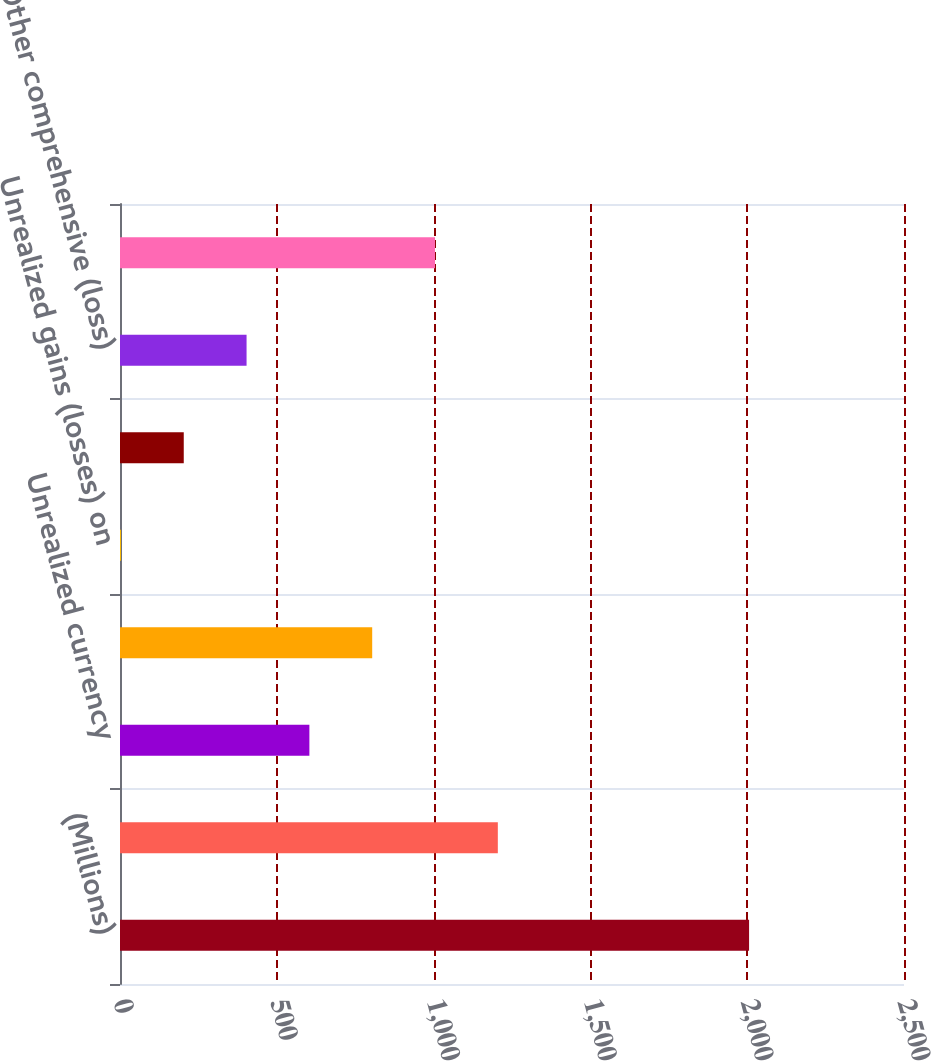Convert chart. <chart><loc_0><loc_0><loc_500><loc_500><bar_chart><fcel>(Millions)<fcel>Net income<fcel>Unrealized currency<fcel>Defined benefit pension plans<fcel>Unrealized gains (losses) on<fcel>Net change - derivatives (See<fcel>Other comprehensive (loss)<fcel>Comprehensive income<nl><fcel>2006<fcel>1204.8<fcel>603.9<fcel>804.2<fcel>3<fcel>203.3<fcel>403.6<fcel>1004.5<nl></chart> 